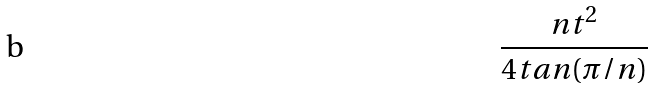<formula> <loc_0><loc_0><loc_500><loc_500>\frac { n t ^ { 2 } } { 4 t a n ( \pi / n ) }</formula> 